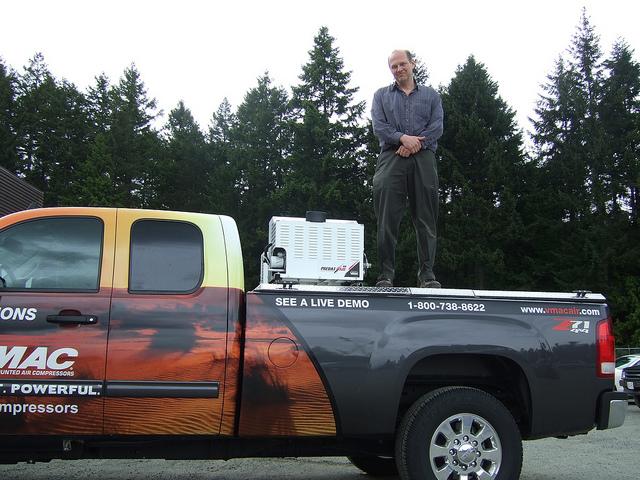Do they have a toll-free number?
Give a very brief answer. Yes. What kind of demo can be seen according to what's written on the truck?
Write a very short answer. Live. Is the man standing on the ground?
Be succinct. No. 